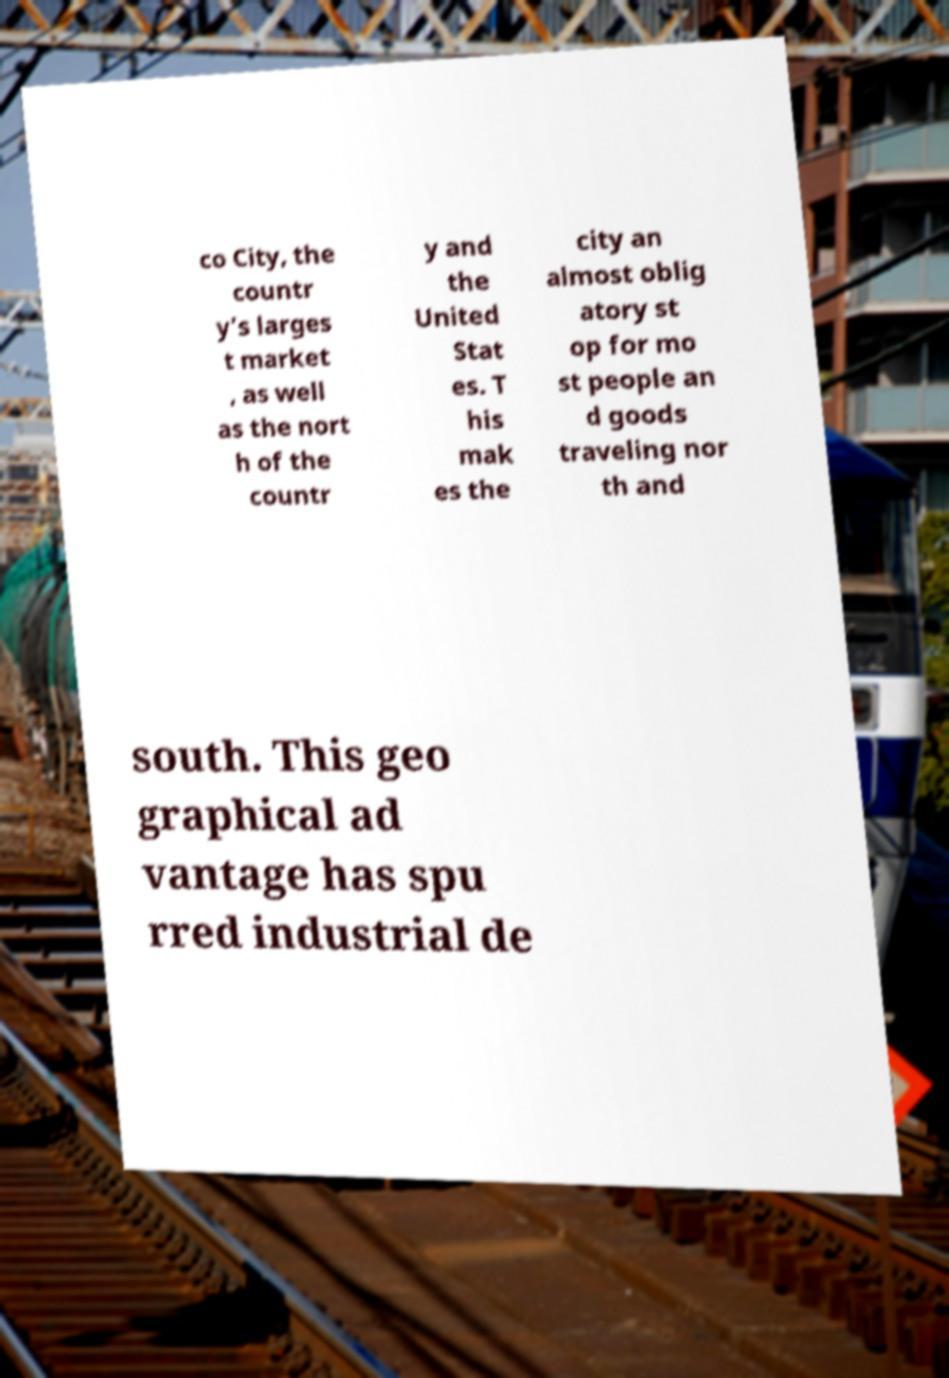Please identify and transcribe the text found in this image. co City, the countr y’s larges t market , as well as the nort h of the countr y and the United Stat es. T his mak es the city an almost oblig atory st op for mo st people an d goods traveling nor th and south. This geo graphical ad vantage has spu rred industrial de 